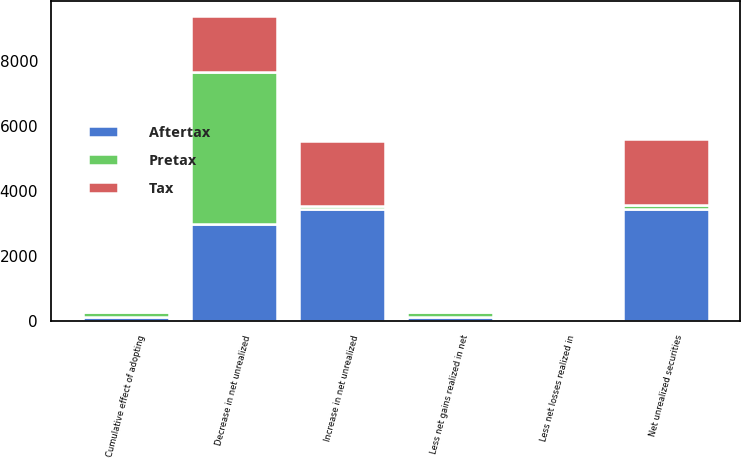Convert chart. <chart><loc_0><loc_0><loc_500><loc_500><stacked_bar_chart><ecel><fcel>Increase in net unrealized<fcel>Less net losses realized in<fcel>Net unrealized securities<fcel>Decrease in net unrealized<fcel>Less net gains realized in net<fcel>Cumulative effect of adopting<nl><fcel>Pretax<fcel>117.5<fcel>9<fcel>117.5<fcel>4692<fcel>167<fcel>174<nl><fcel>Tax<fcel>1992<fcel>3<fcel>2008<fcel>1721<fcel>62<fcel>64<nl><fcel>Aftertax<fcel>3431<fcel>6<fcel>3459<fcel>2971<fcel>105<fcel>110<nl></chart> 